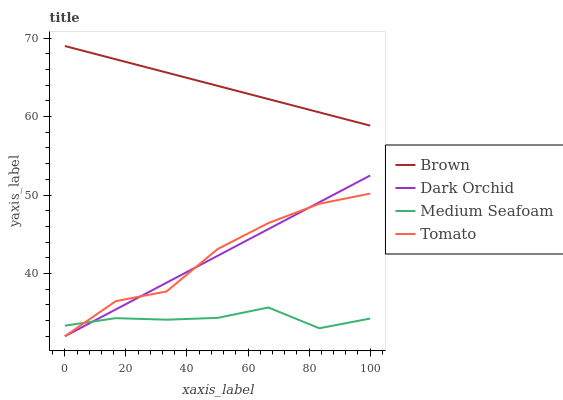Does Medium Seafoam have the minimum area under the curve?
Answer yes or no. Yes. Does Brown have the maximum area under the curve?
Answer yes or no. Yes. Does Brown have the minimum area under the curve?
Answer yes or no. No. Does Medium Seafoam have the maximum area under the curve?
Answer yes or no. No. Is Dark Orchid the smoothest?
Answer yes or no. Yes. Is Tomato the roughest?
Answer yes or no. Yes. Is Brown the smoothest?
Answer yes or no. No. Is Brown the roughest?
Answer yes or no. No. Does Medium Seafoam have the lowest value?
Answer yes or no. No. Does Medium Seafoam have the highest value?
Answer yes or no. No. Is Dark Orchid less than Brown?
Answer yes or no. Yes. Is Brown greater than Dark Orchid?
Answer yes or no. Yes. Does Dark Orchid intersect Brown?
Answer yes or no. No. 